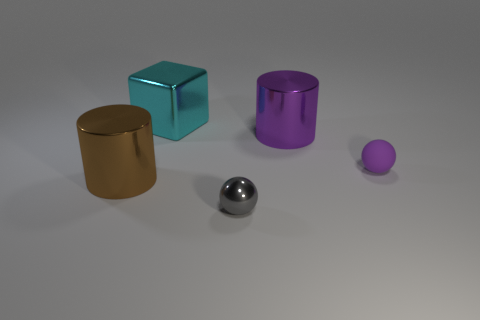What is the material of the big object that is the same color as the rubber ball?
Offer a very short reply. Metal. What color is the sphere that is behind the tiny gray thing?
Give a very brief answer. Purple. There is a cylinder that is in front of the shiny cylinder that is right of the big cyan block; what size is it?
Offer a terse response. Large. There is a big metallic thing that is left of the metallic cube; is it the same shape as the gray thing?
Your response must be concise. No. There is another object that is the same shape as the tiny purple thing; what is its material?
Offer a terse response. Metal. How many objects are big metal cylinders that are to the right of the big cyan thing or large cylinders that are left of the gray shiny thing?
Your answer should be very brief. 2. There is a block; is its color the same as the big object that is in front of the tiny rubber ball?
Keep it short and to the point. No. The gray thing that is the same material as the cyan cube is what shape?
Offer a very short reply. Sphere. How many big cyan things are there?
Your answer should be compact. 1. What number of objects are large shiny objects on the left side of the large cyan cube or blue shiny objects?
Ensure brevity in your answer.  1. 